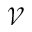<formula> <loc_0><loc_0><loc_500><loc_500>\mathcal { V }</formula> 